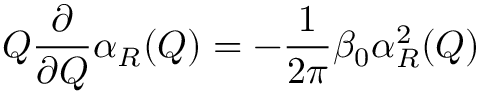<formula> <loc_0><loc_0><loc_500><loc_500>Q \frac { \partial } { \partial Q } \alpha _ { R } ( Q ) = - \frac { 1 } { 2 \pi } \beta _ { 0 } \alpha _ { R } ^ { 2 } ( Q )</formula> 